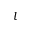Convert formula to latex. <formula><loc_0><loc_0><loc_500><loc_500>l</formula> 